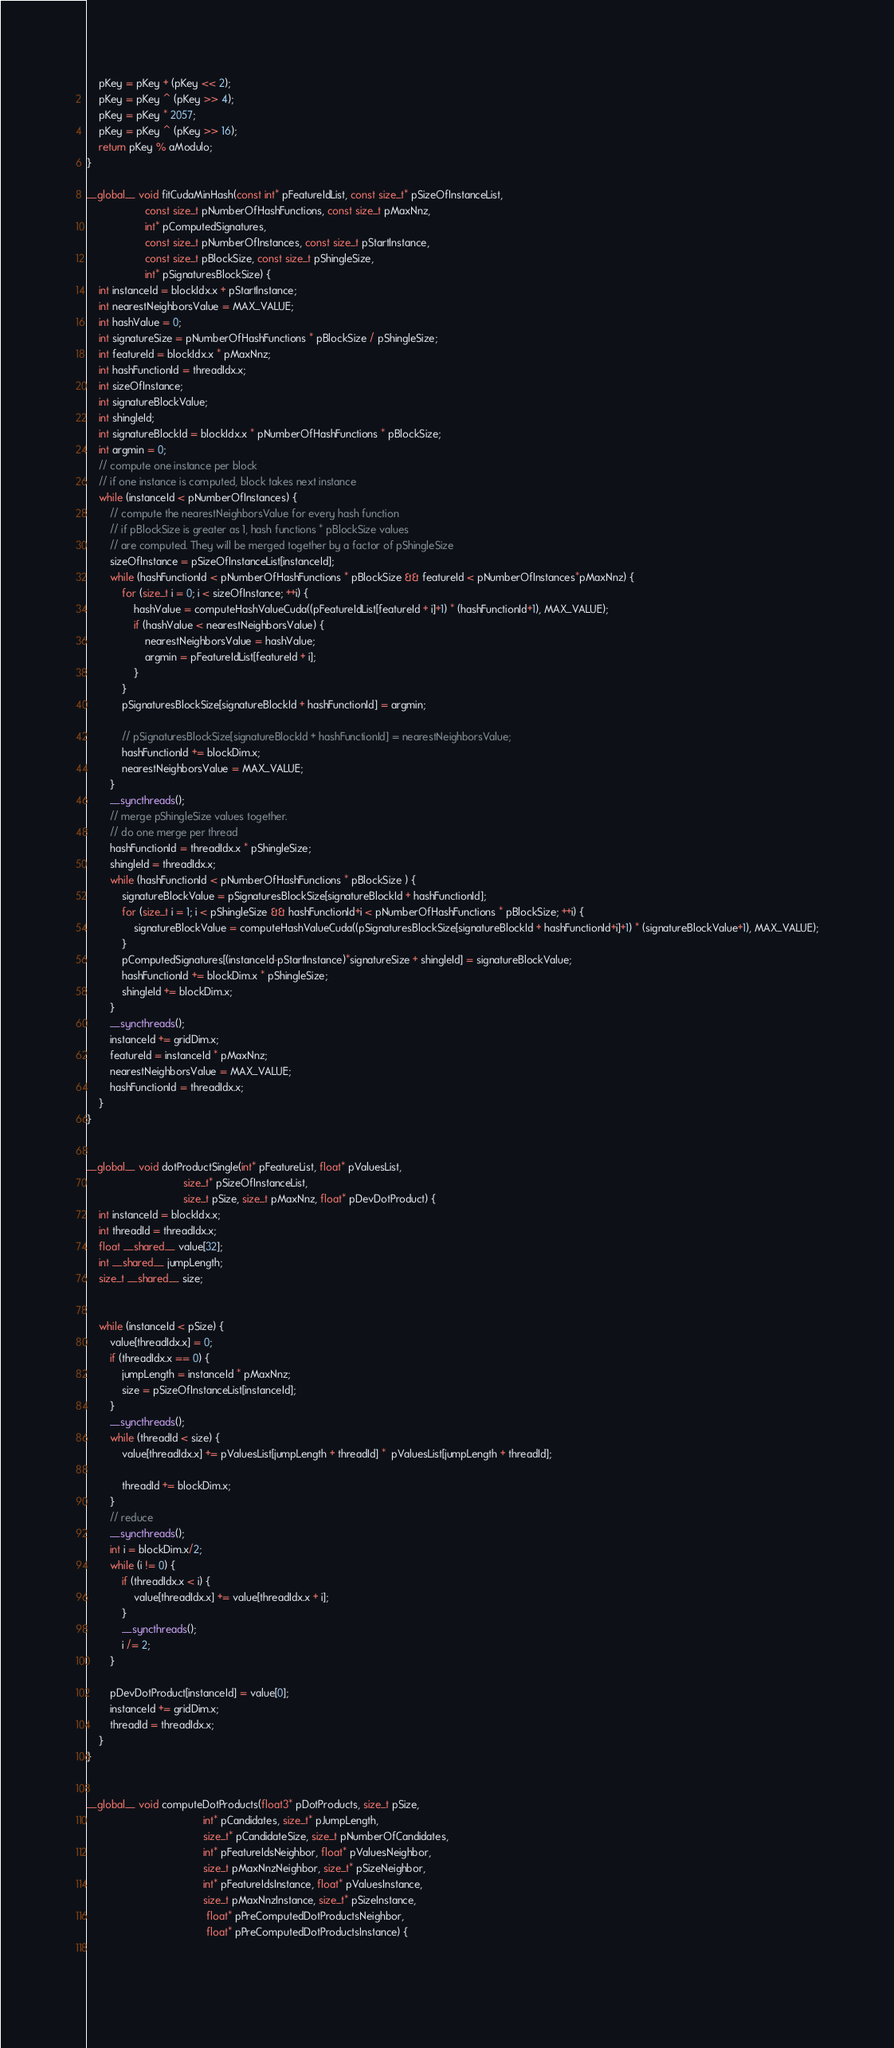<code> <loc_0><loc_0><loc_500><loc_500><_Cuda_>    pKey = pKey + (pKey << 2);
    pKey = pKey ^ (pKey >> 4);
    pKey = pKey * 2057;
    pKey = pKey ^ (pKey >> 16);
    return pKey % aModulo;
}

__global__ void fitCudaMinHash(const int* pFeatureIdList, const size_t* pSizeOfInstanceList,
                    const size_t pNumberOfHashFunctions, const size_t pMaxNnz,
                    int* pComputedSignatures, 
                    const size_t pNumberOfInstances, const size_t pStartInstance, 
                    const size_t pBlockSize, const size_t pShingleSize,
                    int* pSignaturesBlockSize) {
    int instanceId = blockIdx.x + pStartInstance;
    int nearestNeighborsValue = MAX_VALUE;
    int hashValue = 0;
    int signatureSize = pNumberOfHashFunctions * pBlockSize / pShingleSize;
    int featureId = blockIdx.x * pMaxNnz;
    int hashFunctionId = threadIdx.x;
    int sizeOfInstance;
    int signatureBlockValue;
    int shingleId;
    int signatureBlockId = blockIdx.x * pNumberOfHashFunctions * pBlockSize;
    int argmin = 0;
    // compute one instance per block
    // if one instance is computed, block takes next instance
    while (instanceId < pNumberOfInstances) {
        // compute the nearestNeighborsValue for every hash function
        // if pBlockSize is greater as 1, hash functions * pBlockSize values 
        // are computed. They will be merged together by a factor of pShingleSize
        sizeOfInstance = pSizeOfInstanceList[instanceId];
        while (hashFunctionId < pNumberOfHashFunctions * pBlockSize && featureId < pNumberOfInstances*pMaxNnz) {
            for (size_t i = 0; i < sizeOfInstance; ++i) {
                hashValue = computeHashValueCuda((pFeatureIdList[featureId + i]+1) * (hashFunctionId+1), MAX_VALUE);
                if (hashValue < nearestNeighborsValue) {
                    nearestNeighborsValue = hashValue;
                    argmin = pFeatureIdList[featureId + i];
                }
            }
            pSignaturesBlockSize[signatureBlockId + hashFunctionId] = argmin;
            
            // pSignaturesBlockSize[signatureBlockId + hashFunctionId] = nearestNeighborsValue;
            hashFunctionId += blockDim.x;
            nearestNeighborsValue = MAX_VALUE;
        }
        __syncthreads();
        // merge pShingleSize values together.
        // do one merge per thread
        hashFunctionId = threadIdx.x * pShingleSize;
        shingleId = threadIdx.x;
        while (hashFunctionId < pNumberOfHashFunctions * pBlockSize ) {
            signatureBlockValue = pSignaturesBlockSize[signatureBlockId + hashFunctionId];
            for (size_t i = 1; i < pShingleSize && hashFunctionId+i < pNumberOfHashFunctions * pBlockSize; ++i) {
                signatureBlockValue = computeHashValueCuda((pSignaturesBlockSize[signatureBlockId + hashFunctionId+i]+1) * (signatureBlockValue+1), MAX_VALUE);
            }
            pComputedSignatures[(instanceId-pStartInstance)*signatureSize + shingleId] = signatureBlockValue;
            hashFunctionId += blockDim.x * pShingleSize;
            shingleId += blockDim.x;
        }
        __syncthreads();
        instanceId += gridDim.x;
        featureId = instanceId * pMaxNnz;
        nearestNeighborsValue = MAX_VALUE;
        hashFunctionId = threadIdx.x;
    }
}


__global__ void dotProductSingle(int* pFeatureList, float* pValuesList,
                                 size_t* pSizeOfInstanceList,
                                 size_t pSize, size_t pMaxNnz, float* pDevDotProduct) {
    int instanceId = blockIdx.x;
    int threadId = threadIdx.x;
    float __shared__ value[32];
    int __shared__ jumpLength;
    size_t __shared__ size;
    
    
    while (instanceId < pSize) {
        value[threadIdx.x] = 0;
        if (threadIdx.x == 0) {
            jumpLength = instanceId * pMaxNnz;
            size = pSizeOfInstanceList[instanceId];
        }
        __syncthreads();
        while (threadId < size) {
            value[threadIdx.x] += pValuesList[jumpLength + threadId] *  pValuesList[jumpLength + threadId];
            
            threadId += blockDim.x;
        }
        // reduce
        __syncthreads();
        int i = blockDim.x/2;
        while (i != 0) {
            if (threadIdx.x < i) { 
                value[threadIdx.x] += value[threadIdx.x + i];
            }
            __syncthreads();
            i /= 2;
        }
            
        pDevDotProduct[instanceId] = value[0];
        instanceId += gridDim.x;
        threadId = threadIdx.x;
    }                                
}


__global__ void computeDotProducts(float3* pDotProducts, size_t pSize, 
                                        int* pCandidates, size_t* pJumpLength, 
                                        size_t* pCandidateSize, size_t pNumberOfCandidates,
                                        int* pFeatureIdsNeighbor, float* pValuesNeighbor, 
                                        size_t pMaxNnzNeighbor, size_t* pSizeNeighbor,
                                        int* pFeatureIdsInstance, float* pValuesInstance,
                                        size_t pMaxNnzInstance, size_t* pSizeInstance,
                                         float* pPreComputedDotProductsNeighbor, 
                                         float* pPreComputedDotProductsInstance) {
    
      </code> 